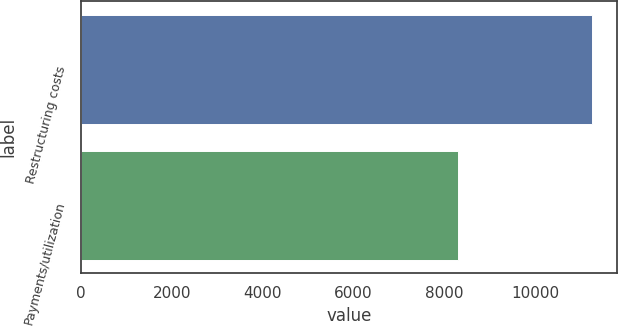<chart> <loc_0><loc_0><loc_500><loc_500><bar_chart><fcel>Restructuring costs<fcel>Payments/utilization<nl><fcel>11251<fcel>8300<nl></chart> 